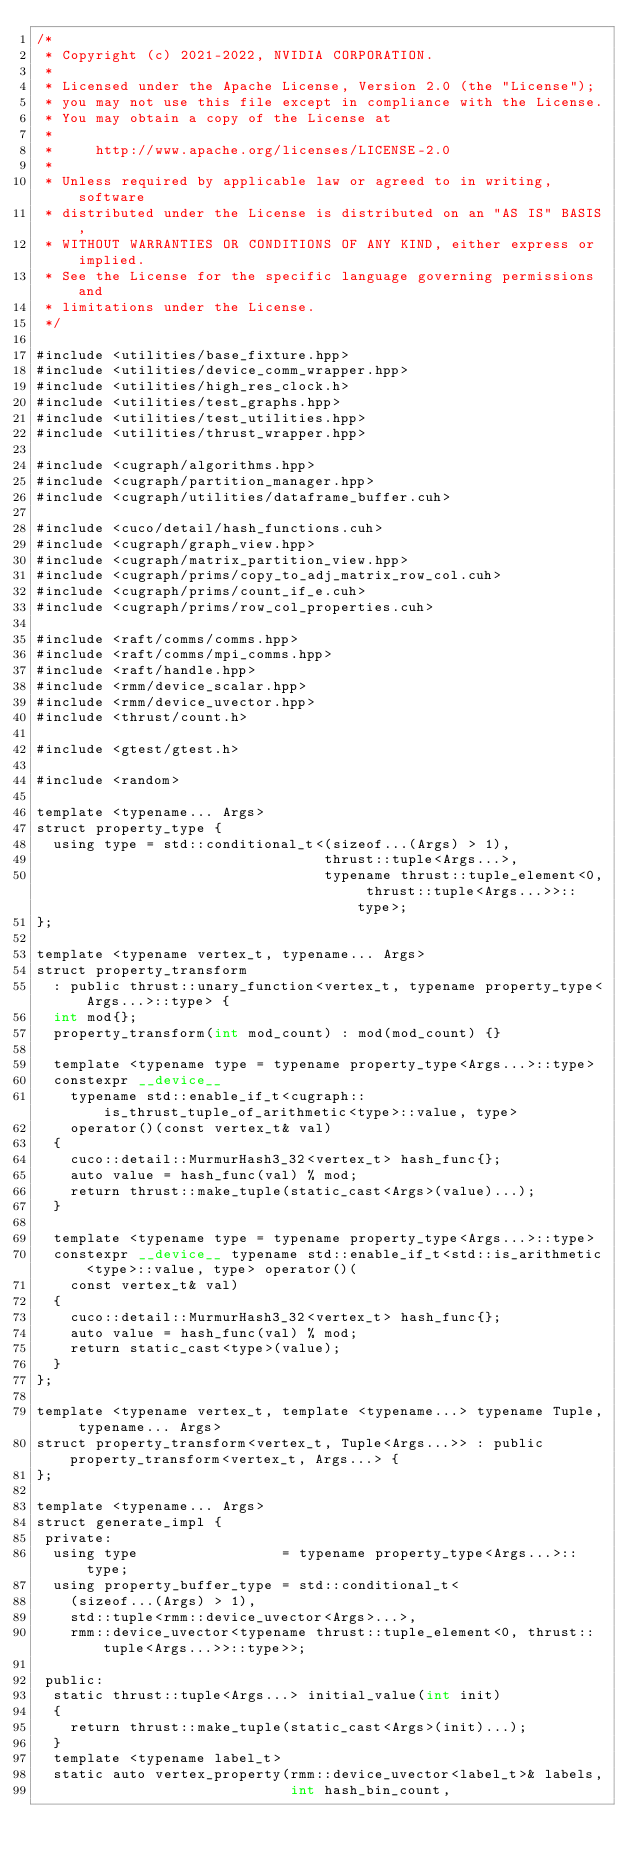Convert code to text. <code><loc_0><loc_0><loc_500><loc_500><_Cuda_>/*
 * Copyright (c) 2021-2022, NVIDIA CORPORATION.
 *
 * Licensed under the Apache License, Version 2.0 (the "License");
 * you may not use this file except in compliance with the License.
 * You may obtain a copy of the License at
 *
 *     http://www.apache.org/licenses/LICENSE-2.0
 *
 * Unless required by applicable law or agreed to in writing, software
 * distributed under the License is distributed on an "AS IS" BASIS,
 * WITHOUT WARRANTIES OR CONDITIONS OF ANY KIND, either express or implied.
 * See the License for the specific language governing permissions and
 * limitations under the License.
 */

#include <utilities/base_fixture.hpp>
#include <utilities/device_comm_wrapper.hpp>
#include <utilities/high_res_clock.h>
#include <utilities/test_graphs.hpp>
#include <utilities/test_utilities.hpp>
#include <utilities/thrust_wrapper.hpp>

#include <cugraph/algorithms.hpp>
#include <cugraph/partition_manager.hpp>
#include <cugraph/utilities/dataframe_buffer.cuh>

#include <cuco/detail/hash_functions.cuh>
#include <cugraph/graph_view.hpp>
#include <cugraph/matrix_partition_view.hpp>
#include <cugraph/prims/copy_to_adj_matrix_row_col.cuh>
#include <cugraph/prims/count_if_e.cuh>
#include <cugraph/prims/row_col_properties.cuh>

#include <raft/comms/comms.hpp>
#include <raft/comms/mpi_comms.hpp>
#include <raft/handle.hpp>
#include <rmm/device_scalar.hpp>
#include <rmm/device_uvector.hpp>
#include <thrust/count.h>

#include <gtest/gtest.h>

#include <random>

template <typename... Args>
struct property_type {
  using type = std::conditional_t<(sizeof...(Args) > 1),
                                  thrust::tuple<Args...>,
                                  typename thrust::tuple_element<0, thrust::tuple<Args...>>::type>;
};

template <typename vertex_t, typename... Args>
struct property_transform
  : public thrust::unary_function<vertex_t, typename property_type<Args...>::type> {
  int mod{};
  property_transform(int mod_count) : mod(mod_count) {}

  template <typename type = typename property_type<Args...>::type>
  constexpr __device__
    typename std::enable_if_t<cugraph::is_thrust_tuple_of_arithmetic<type>::value, type>
    operator()(const vertex_t& val)
  {
    cuco::detail::MurmurHash3_32<vertex_t> hash_func{};
    auto value = hash_func(val) % mod;
    return thrust::make_tuple(static_cast<Args>(value)...);
  }

  template <typename type = typename property_type<Args...>::type>
  constexpr __device__ typename std::enable_if_t<std::is_arithmetic<type>::value, type> operator()(
    const vertex_t& val)
  {
    cuco::detail::MurmurHash3_32<vertex_t> hash_func{};
    auto value = hash_func(val) % mod;
    return static_cast<type>(value);
  }
};

template <typename vertex_t, template <typename...> typename Tuple, typename... Args>
struct property_transform<vertex_t, Tuple<Args...>> : public property_transform<vertex_t, Args...> {
};

template <typename... Args>
struct generate_impl {
 private:
  using type                 = typename property_type<Args...>::type;
  using property_buffer_type = std::conditional_t<
    (sizeof...(Args) > 1),
    std::tuple<rmm::device_uvector<Args>...>,
    rmm::device_uvector<typename thrust::tuple_element<0, thrust::tuple<Args...>>::type>>;

 public:
  static thrust::tuple<Args...> initial_value(int init)
  {
    return thrust::make_tuple(static_cast<Args>(init)...);
  }
  template <typename label_t>
  static auto vertex_property(rmm::device_uvector<label_t>& labels,
                              int hash_bin_count,</code> 